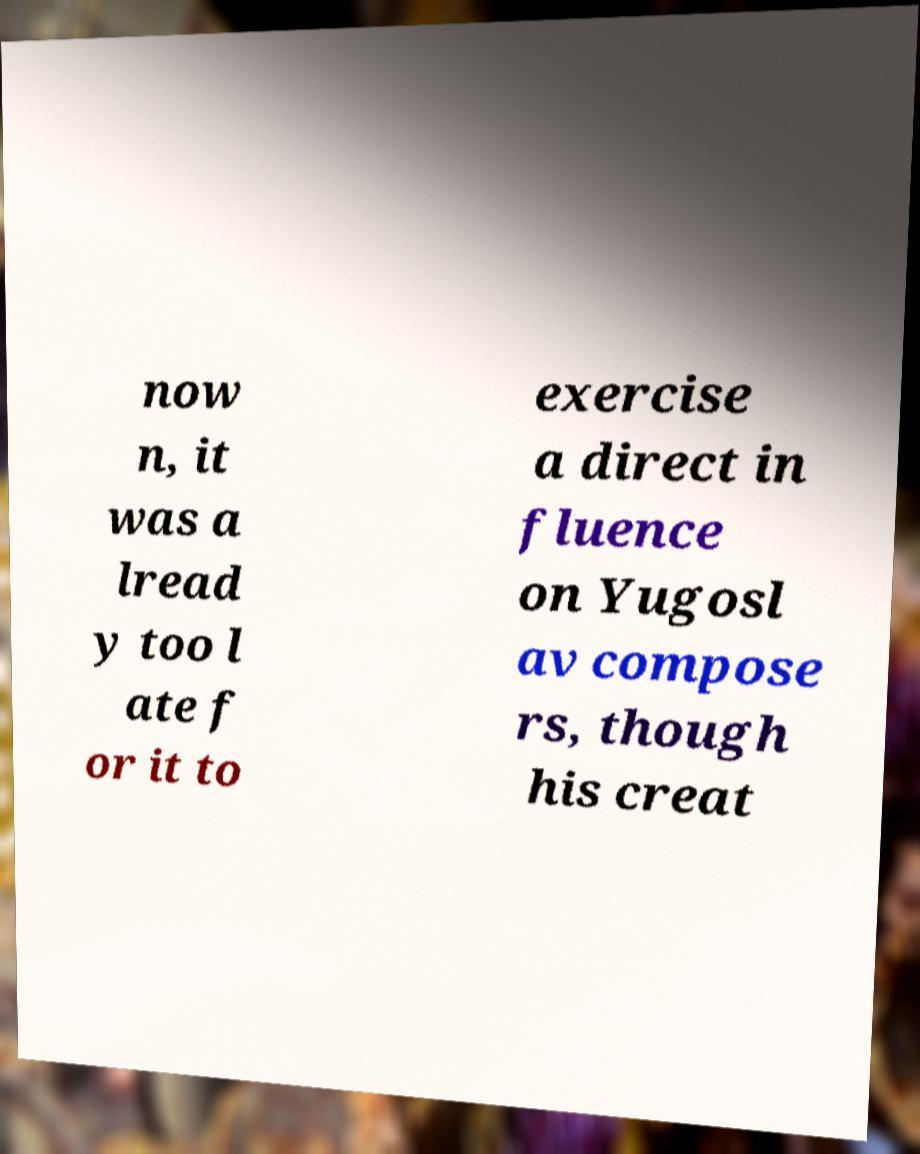For documentation purposes, I need the text within this image transcribed. Could you provide that? now n, it was a lread y too l ate f or it to exercise a direct in fluence on Yugosl av compose rs, though his creat 